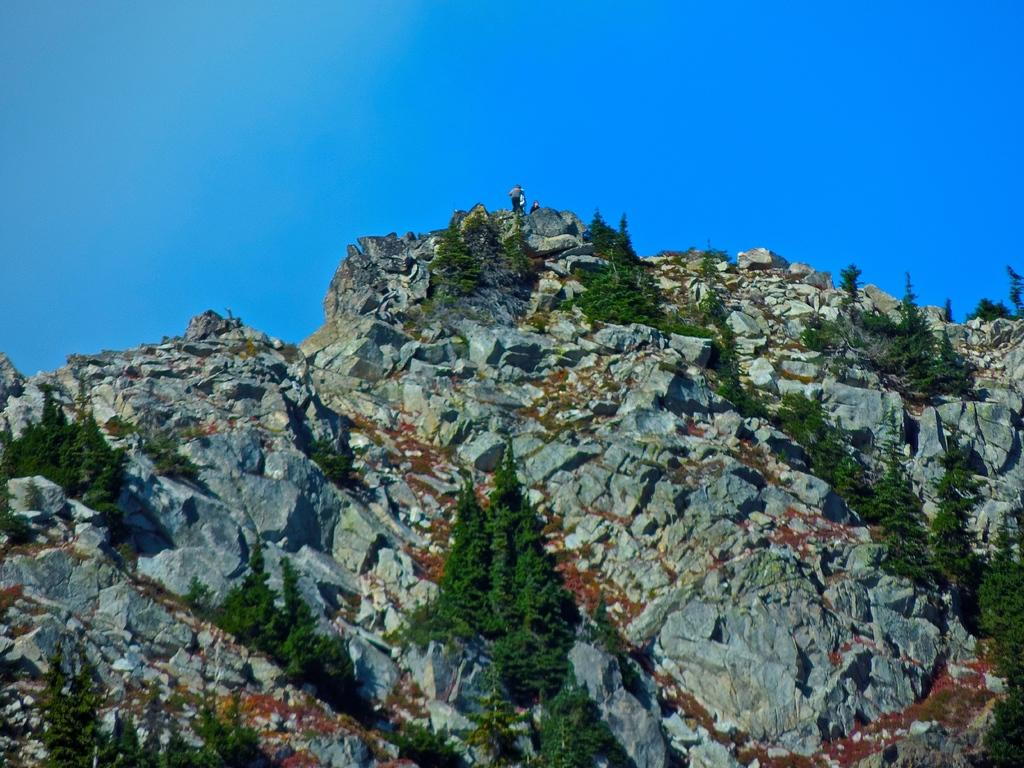What are the people in the image doing? The people in the image are standing on a mountain. What can be seen in the background of the image? There are trees visible in the image. What is visible above the people and trees in the image? The sky is visible in the image. What time of day is it in the image, based on the hour? The provided facts do not mention the time of day or any specific hour, so it cannot be determined from the image. 